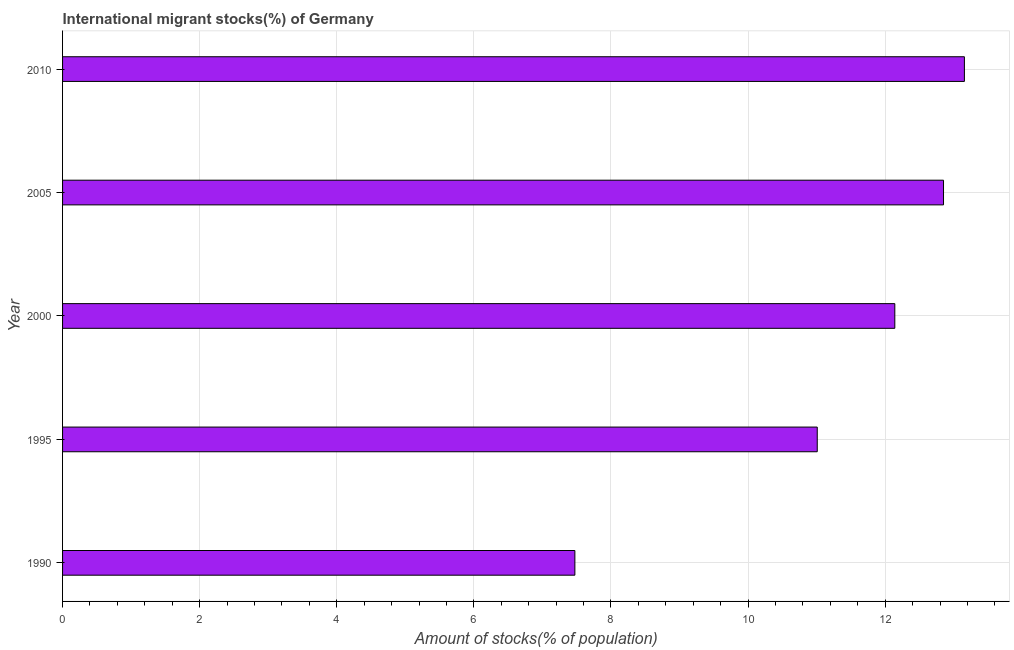Does the graph contain any zero values?
Give a very brief answer. No. Does the graph contain grids?
Your answer should be very brief. Yes. What is the title of the graph?
Make the answer very short. International migrant stocks(%) of Germany. What is the label or title of the X-axis?
Provide a succinct answer. Amount of stocks(% of population). What is the label or title of the Y-axis?
Provide a short and direct response. Year. What is the number of international migrant stocks in 2000?
Your response must be concise. 12.14. Across all years, what is the maximum number of international migrant stocks?
Your answer should be compact. 13.16. Across all years, what is the minimum number of international migrant stocks?
Your response must be concise. 7.47. What is the sum of the number of international migrant stocks?
Offer a very short reply. 56.63. What is the difference between the number of international migrant stocks in 1990 and 1995?
Provide a short and direct response. -3.54. What is the average number of international migrant stocks per year?
Give a very brief answer. 11.33. What is the median number of international migrant stocks?
Ensure brevity in your answer.  12.14. Do a majority of the years between 1990 and 1995 (inclusive) have number of international migrant stocks greater than 1.6 %?
Give a very brief answer. Yes. What is the ratio of the number of international migrant stocks in 1995 to that in 2010?
Offer a terse response. 0.84. Is the number of international migrant stocks in 1990 less than that in 2010?
Provide a succinct answer. Yes. Is the difference between the number of international migrant stocks in 1995 and 2005 greater than the difference between any two years?
Give a very brief answer. No. What is the difference between the highest and the second highest number of international migrant stocks?
Make the answer very short. 0.3. What is the difference between the highest and the lowest number of international migrant stocks?
Ensure brevity in your answer.  5.68. In how many years, is the number of international migrant stocks greater than the average number of international migrant stocks taken over all years?
Offer a terse response. 3. How many years are there in the graph?
Your response must be concise. 5. Are the values on the major ticks of X-axis written in scientific E-notation?
Ensure brevity in your answer.  No. What is the Amount of stocks(% of population) of 1990?
Provide a short and direct response. 7.47. What is the Amount of stocks(% of population) of 1995?
Give a very brief answer. 11.01. What is the Amount of stocks(% of population) of 2000?
Keep it short and to the point. 12.14. What is the Amount of stocks(% of population) of 2005?
Provide a short and direct response. 12.85. What is the Amount of stocks(% of population) of 2010?
Give a very brief answer. 13.16. What is the difference between the Amount of stocks(% of population) in 1990 and 1995?
Make the answer very short. -3.54. What is the difference between the Amount of stocks(% of population) in 1990 and 2000?
Keep it short and to the point. -4.67. What is the difference between the Amount of stocks(% of population) in 1990 and 2005?
Offer a very short reply. -5.38. What is the difference between the Amount of stocks(% of population) in 1990 and 2010?
Offer a terse response. -5.68. What is the difference between the Amount of stocks(% of population) in 1995 and 2000?
Provide a short and direct response. -1.13. What is the difference between the Amount of stocks(% of population) in 1995 and 2005?
Your answer should be very brief. -1.84. What is the difference between the Amount of stocks(% of population) in 1995 and 2010?
Offer a terse response. -2.15. What is the difference between the Amount of stocks(% of population) in 2000 and 2005?
Ensure brevity in your answer.  -0.71. What is the difference between the Amount of stocks(% of population) in 2000 and 2010?
Offer a terse response. -1.02. What is the difference between the Amount of stocks(% of population) in 2005 and 2010?
Your answer should be very brief. -0.3. What is the ratio of the Amount of stocks(% of population) in 1990 to that in 1995?
Make the answer very short. 0.68. What is the ratio of the Amount of stocks(% of population) in 1990 to that in 2000?
Your answer should be compact. 0.62. What is the ratio of the Amount of stocks(% of population) in 1990 to that in 2005?
Your response must be concise. 0.58. What is the ratio of the Amount of stocks(% of population) in 1990 to that in 2010?
Ensure brevity in your answer.  0.57. What is the ratio of the Amount of stocks(% of population) in 1995 to that in 2000?
Your answer should be very brief. 0.91. What is the ratio of the Amount of stocks(% of population) in 1995 to that in 2005?
Provide a short and direct response. 0.86. What is the ratio of the Amount of stocks(% of population) in 1995 to that in 2010?
Keep it short and to the point. 0.84. What is the ratio of the Amount of stocks(% of population) in 2000 to that in 2005?
Give a very brief answer. 0.94. What is the ratio of the Amount of stocks(% of population) in 2000 to that in 2010?
Offer a very short reply. 0.92. 